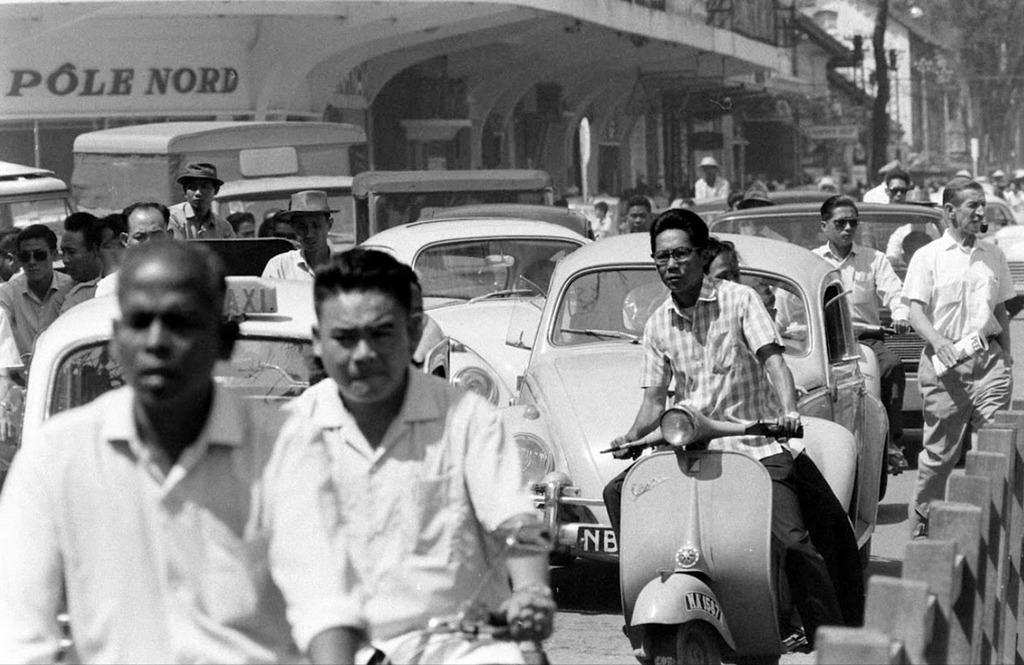Can you describe this image briefly? This is a black and white picture, there are many cars,people walking,riding scooters on the road with a bridge in the back. 